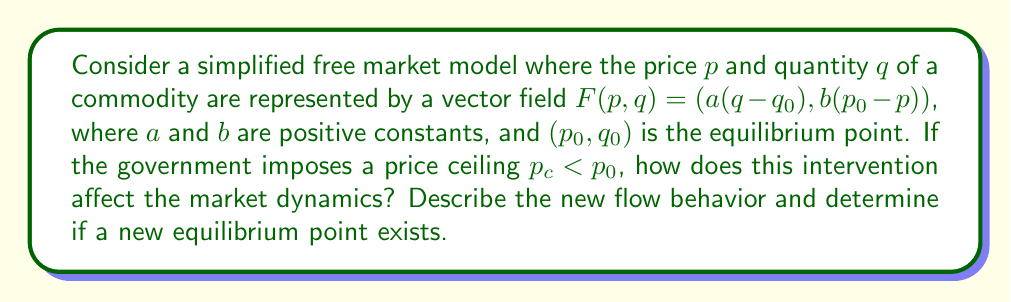Could you help me with this problem? To analyze this problem, we'll follow these steps:

1) First, let's understand the original vector field:
   $$F(p,q) = (a(q-q_0), b(p_0-p))$$
   This field represents the natural tendency of the market to move towards equilibrium $(p_0, q_0)$.

2) The price ceiling $p_c < p_0$ introduces a constraint to our system. We can represent this as:
   $$p \leq p_c$$

3) This constraint modifies our vector field. For $p < p_c$, the field remains unchanged. But for $p = p_c$, the vertical component becomes zero if it's positive:
   $$F(p,q) = \begin{cases}
   (a(q-q_0), b(p_0-p)) & \text{if } p < p_c \text{ or } p = p_c \text{ and } p_0-p_c \leq 0 \\
   (a(q-q_0), 0) & \text{if } p = p_c \text{ and } p_0-p_c > 0
   \end{cases}$$

4) This modification creates a discontinuity in the vector field at $p = p_c$.

5) The flow behavior changes:
   - For $p < p_c$, the flow behaves as before, moving towards $p_0$.
   - At $p = p_c$, the flow can only move horizontally or stay stationary.
   - There's no flow for $p > p_c$ due to the price ceiling.

6) A new equilibrium point exists where the horizontal component of $F$ becomes zero at $p = p_c$:
   $$a(q-q_0) = 0$$
   $$q = q_0$$

   So the new equilibrium point is $(p_c, q_0)$.

7) However, this is not a true equilibrium in the economic sense. At this point:
   - The price is artificially held at $p_c$.
   - There's excess demand: consumers want to buy more at this price than producers are willing to supply.

This intervention disrupts the natural market dynamics, preventing the system from reaching its true equilibrium and potentially leading to shortages.
Answer: The price ceiling modifies the vector field, creating a discontinuity at $p = p_c$. The new flow is constrained to $p \leq p_c$, with horizontal-only flow at $p = p_c$. A new mathematical equilibrium point exists at $(p_c, q_0)$, but this represents a state of disequilibrium in economic terms, with potential shortages due to excess demand at the artificially low price. 